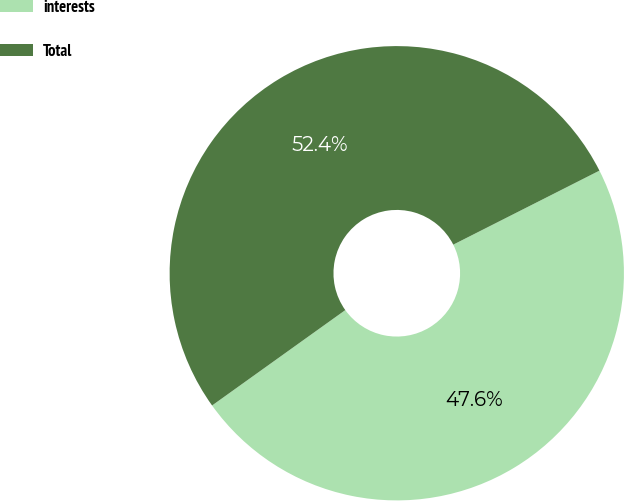Convert chart to OTSL. <chart><loc_0><loc_0><loc_500><loc_500><pie_chart><fcel>interests<fcel>Total<nl><fcel>47.57%<fcel>52.43%<nl></chart> 